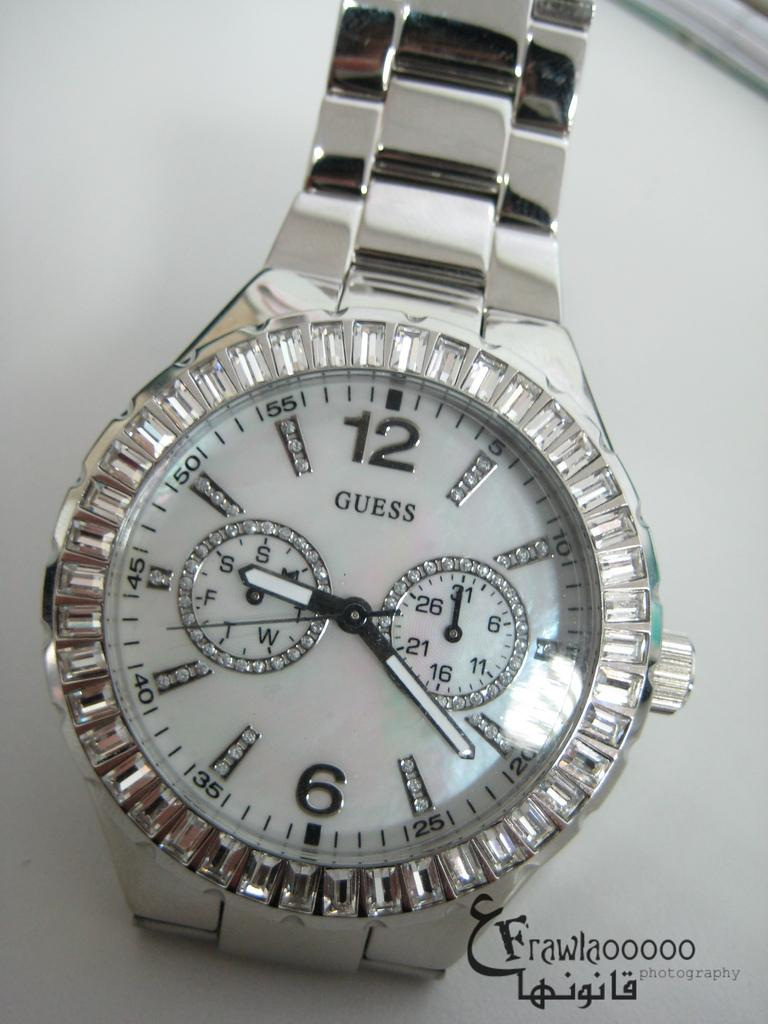<image>
Render a clear and concise summary of the photo. A Guess watch has lots of little crystals on the face. 